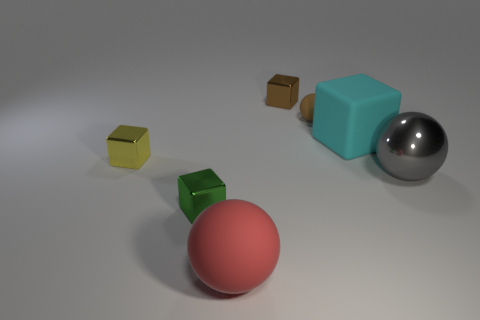How would you describe the lighting in this image and the effect it has on the objects presented? The lighting in this image is soft and diffuse, producing gentle shadows and a calm atmosphere. It highlights the textures of the objects well, with the metal sphere reflecting the light, enhancing its shine, while the matte surfaces of the other objects absorb the light, giving them a subdued look. 